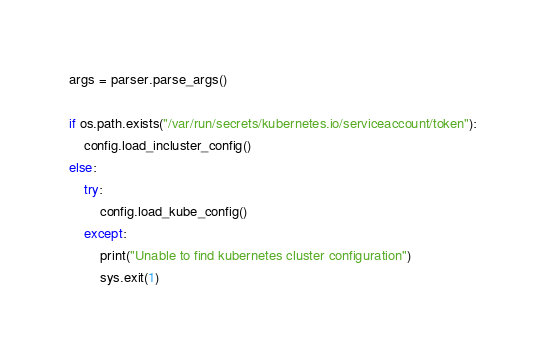Convert code to text. <code><loc_0><loc_0><loc_500><loc_500><_Python_>args = parser.parse_args()

if os.path.exists("/var/run/secrets/kubernetes.io/serviceaccount/token"):
    config.load_incluster_config()
else:
    try:
        config.load_kube_config()
    except:
        print("Unable to find kubernetes cluster configuration")
        sys.exit(1)
</code> 